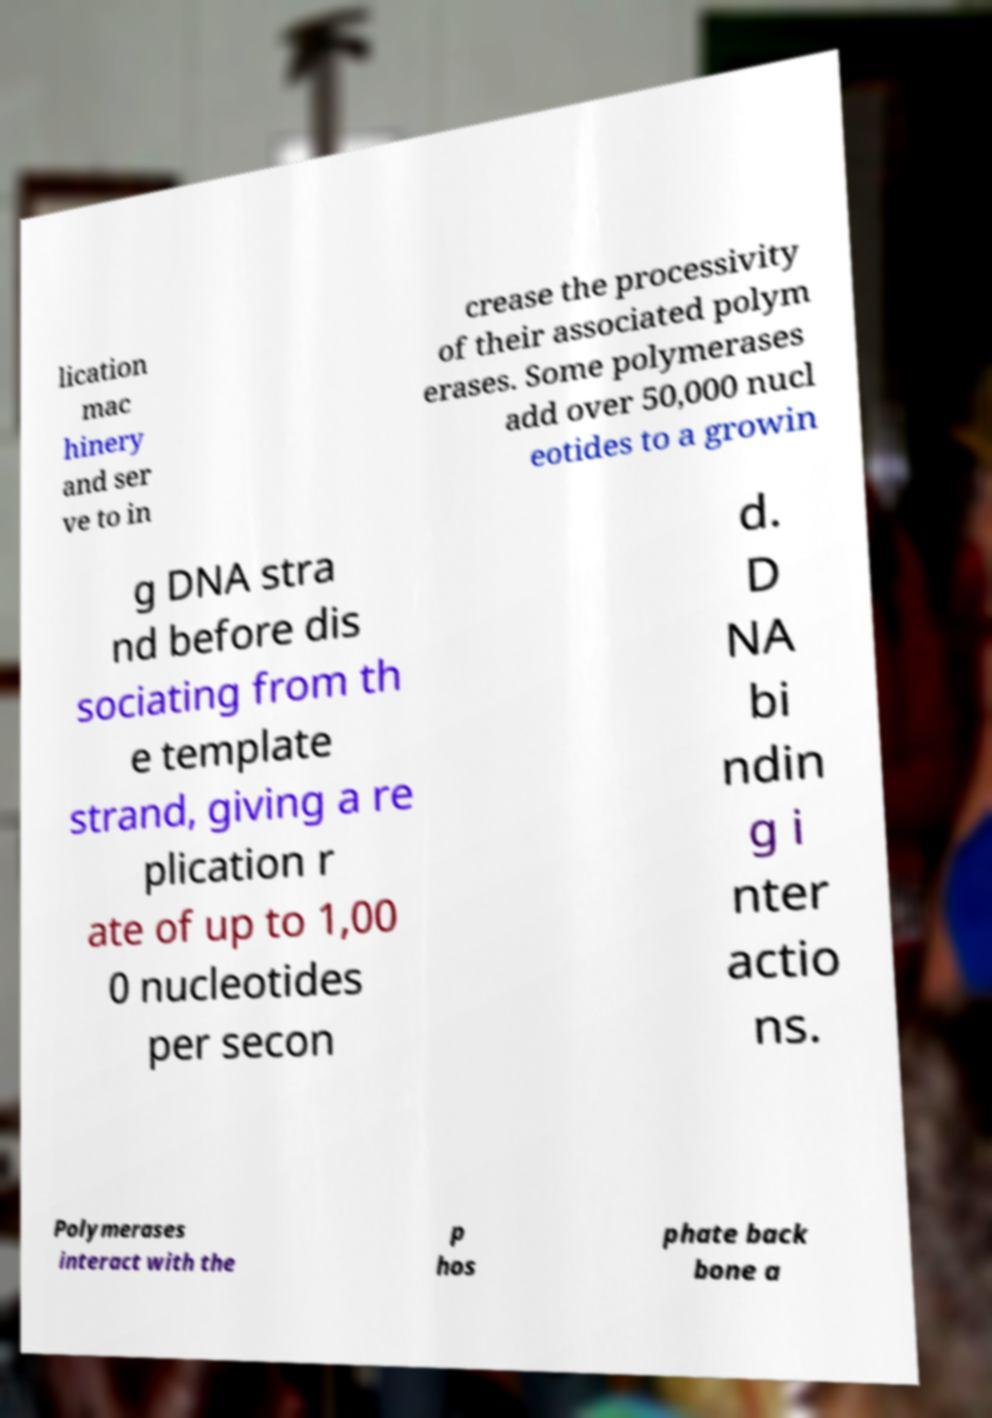Can you accurately transcribe the text from the provided image for me? lication mac hinery and ser ve to in crease the processivity of their associated polym erases. Some polymerases add over 50,000 nucl eotides to a growin g DNA stra nd before dis sociating from th e template strand, giving a re plication r ate of up to 1,00 0 nucleotides per secon d. D NA bi ndin g i nter actio ns. Polymerases interact with the p hos phate back bone a 